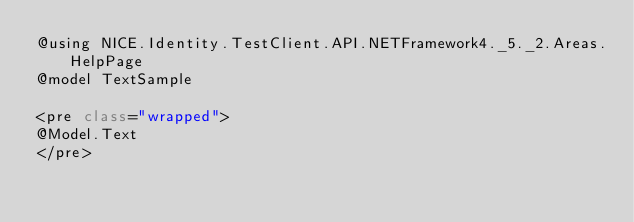<code> <loc_0><loc_0><loc_500><loc_500><_C#_>@using NICE.Identity.TestClient.API.NETFramework4._5._2.Areas.HelpPage
@model TextSample

<pre class="wrapped">
@Model.Text
</pre></code> 